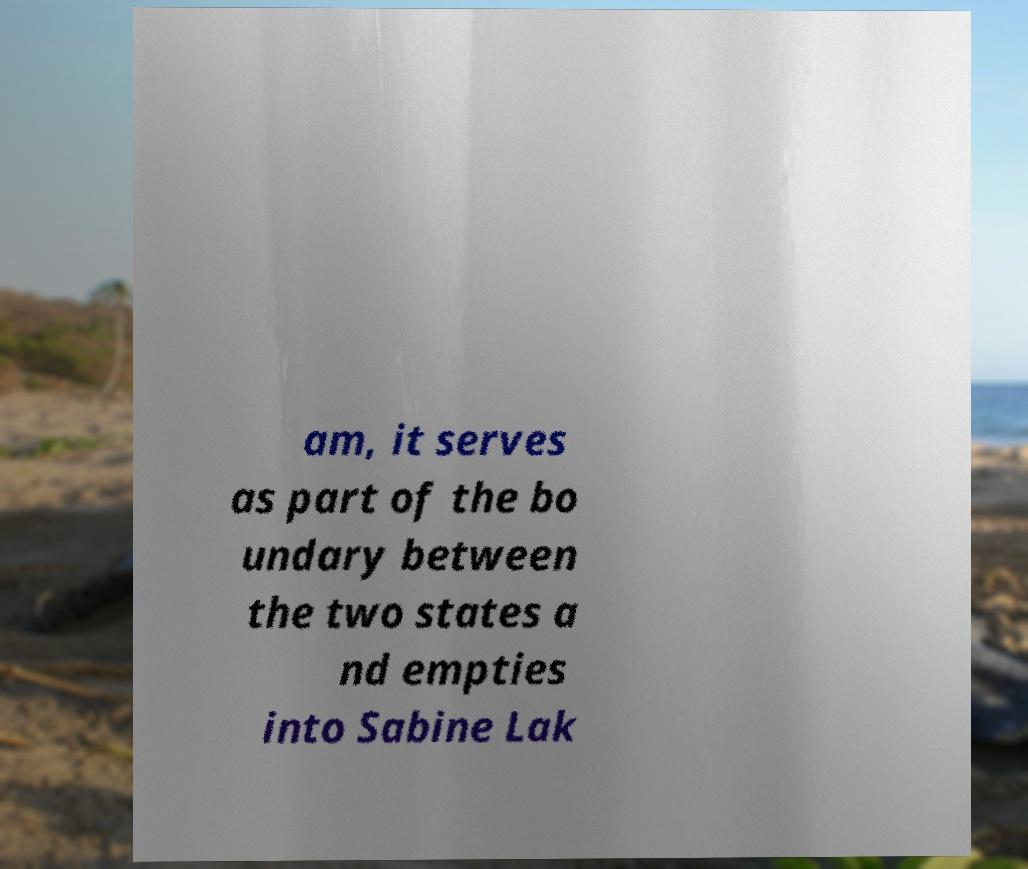There's text embedded in this image that I need extracted. Can you transcribe it verbatim? am, it serves as part of the bo undary between the two states a nd empties into Sabine Lak 